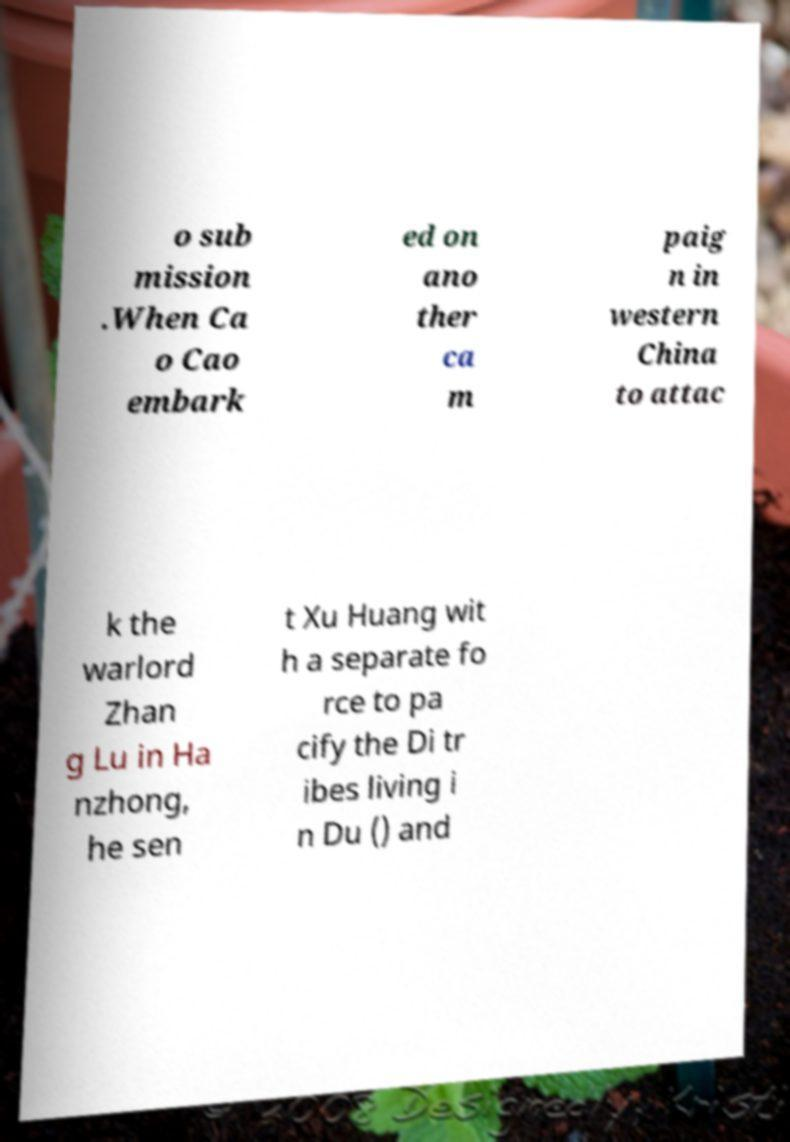Can you read and provide the text displayed in the image?This photo seems to have some interesting text. Can you extract and type it out for me? o sub mission .When Ca o Cao embark ed on ano ther ca m paig n in western China to attac k the warlord Zhan g Lu in Ha nzhong, he sen t Xu Huang wit h a separate fo rce to pa cify the Di tr ibes living i n Du () and 